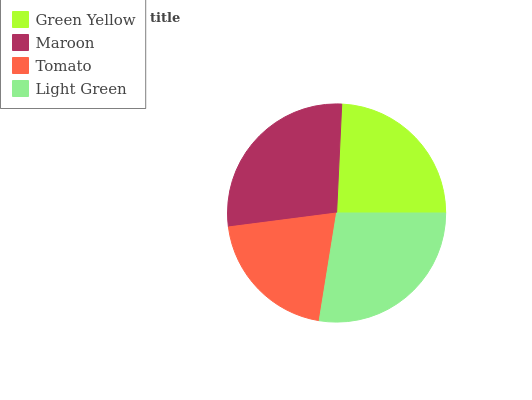Is Tomato the minimum?
Answer yes or no. Yes. Is Maroon the maximum?
Answer yes or no. Yes. Is Maroon the minimum?
Answer yes or no. No. Is Tomato the maximum?
Answer yes or no. No. Is Maroon greater than Tomato?
Answer yes or no. Yes. Is Tomato less than Maroon?
Answer yes or no. Yes. Is Tomato greater than Maroon?
Answer yes or no. No. Is Maroon less than Tomato?
Answer yes or no. No. Is Light Green the high median?
Answer yes or no. Yes. Is Green Yellow the low median?
Answer yes or no. Yes. Is Maroon the high median?
Answer yes or no. No. Is Light Green the low median?
Answer yes or no. No. 